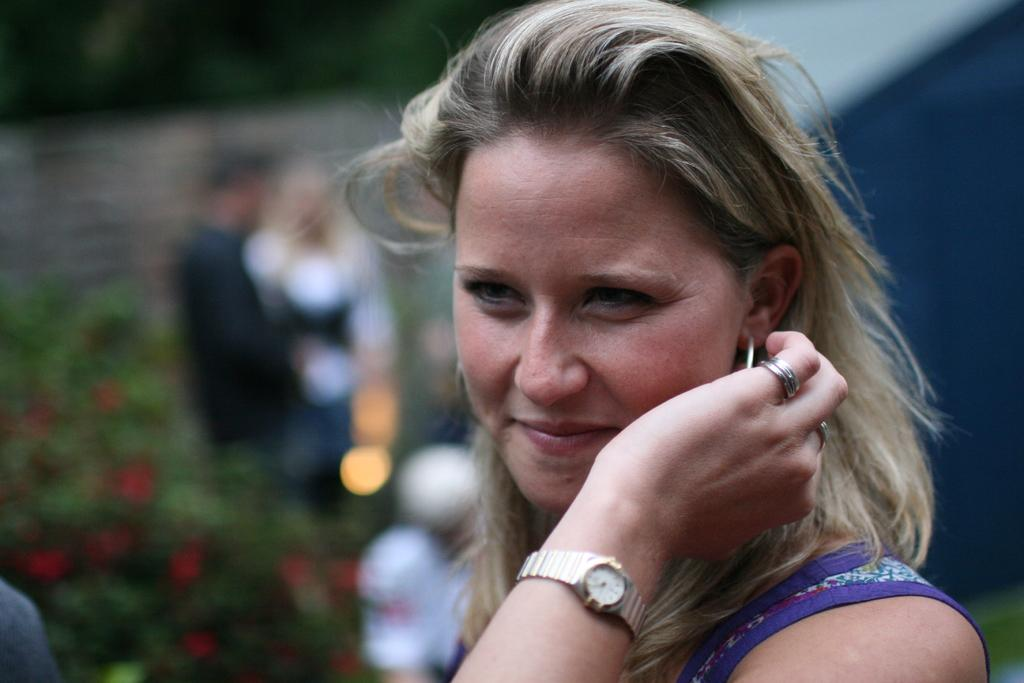Who is the main subject in the image? There is a woman in the image. What is the woman doing in the image? The woman is smiling. Are there any other people in the image? Yes, there is a couple standing behind the woman. What type of plastic material can be seen in the image? There is no plastic material present in the image. How does the woman slip in the image? The woman does not slip in the image; she is standing and smiling. 